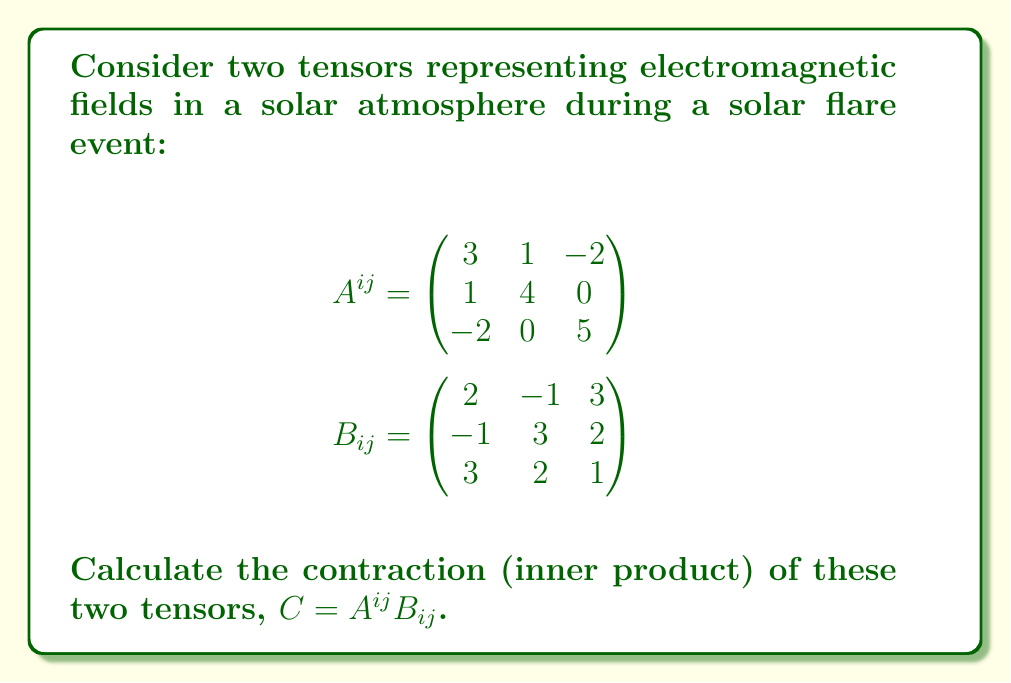What is the answer to this math problem? To calculate the contraction of two tensors $A^{ij}$ and $B_{ij}$, we need to sum over all indices:

$$C = A^{ij}B_{ij} = \sum_{i=1}^3\sum_{j=1}^3 A^{ij}B_{ij}$$

Let's compute this sum step by step:

1) For $i=1, j=1$: $A^{11}B_{11} = 3 \cdot 2 = 6$
2) For $i=1, j=2$: $A^{12}B_{12} = 1 \cdot (-1) = -1$
3) For $i=1, j=3$: $A^{13}B_{13} = (-2) \cdot 3 = -6$
4) For $i=2, j=1$: $A^{21}B_{21} = 1 \cdot (-1) = -1$
5) For $i=2, j=2$: $A^{22}B_{22} = 4 \cdot 3 = 12$
6) For $i=2, j=3$: $A^{23}B_{23} = 0 \cdot 2 = 0$
7) For $i=3, j=1$: $A^{31}B_{31} = (-2) \cdot 3 = -6$
8) For $i=3, j=2$: $A^{32}B_{32} = 0 \cdot 2 = 0$
9) For $i=3, j=3$: $A^{33}B_{33} = 5 \cdot 1 = 5$

Now, we sum all these terms:

$$C = 6 + (-1) + (-6) + (-1) + 12 + 0 + (-6) + 0 + 5 = 9$$

Therefore, the contraction of the two tensors is 9.
Answer: 9 